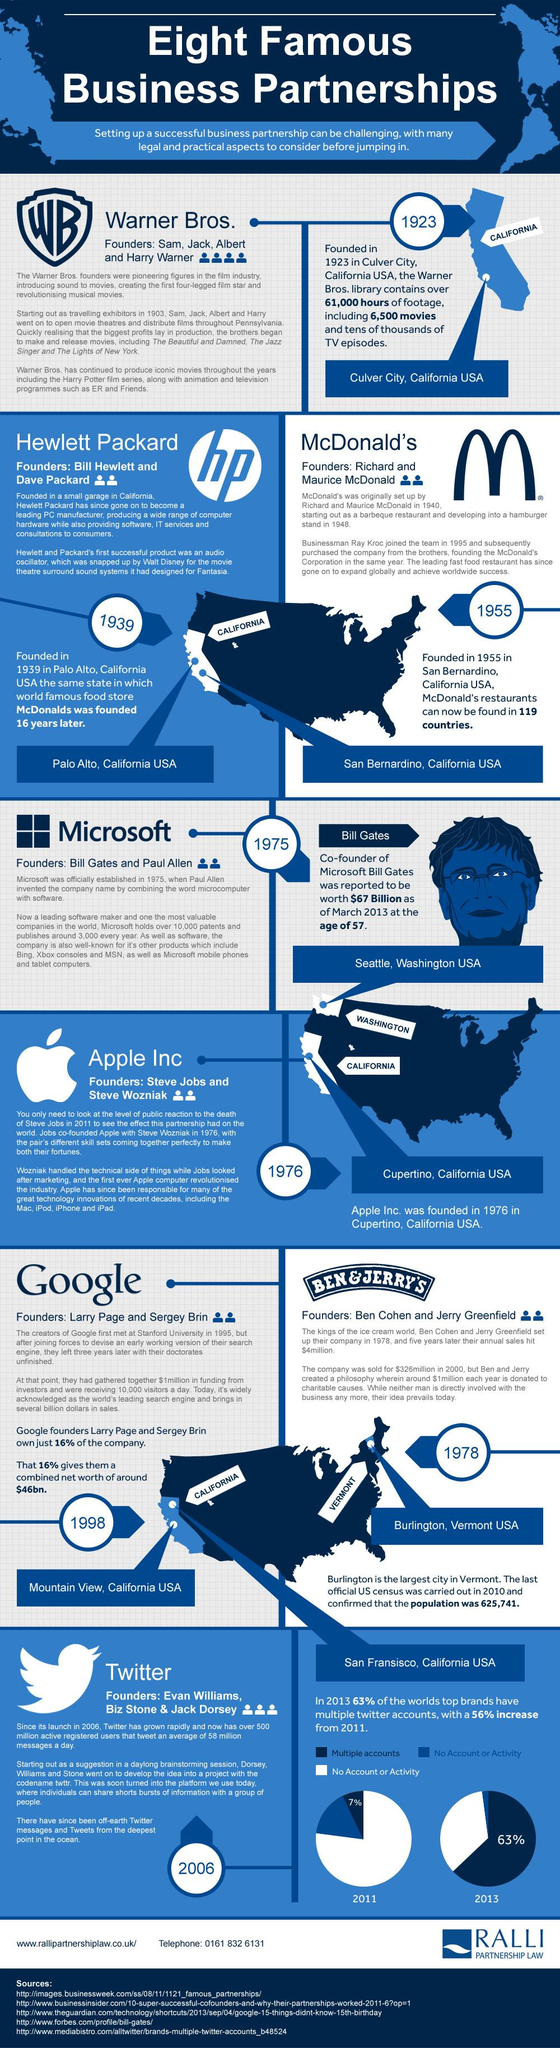Outline some significant characteristics in this image. Apple Inc. had two founders. In 2011, it was found that 93% of top brands did not have a Twitter account or any activity on the platform. Hewlett Packard had two founders. Google had two founders. Google, a technology company known for its search engine and various other products and services, was founded in Mountain View, California, USA. 